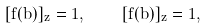Convert formula to latex. <formula><loc_0><loc_0><loc_500><loc_500>[ f ( b ) ] _ { z } = 1 , \quad [ \bar { f } ( \bar { b } ) ] _ { \bar { z } } = 1 ,</formula> 